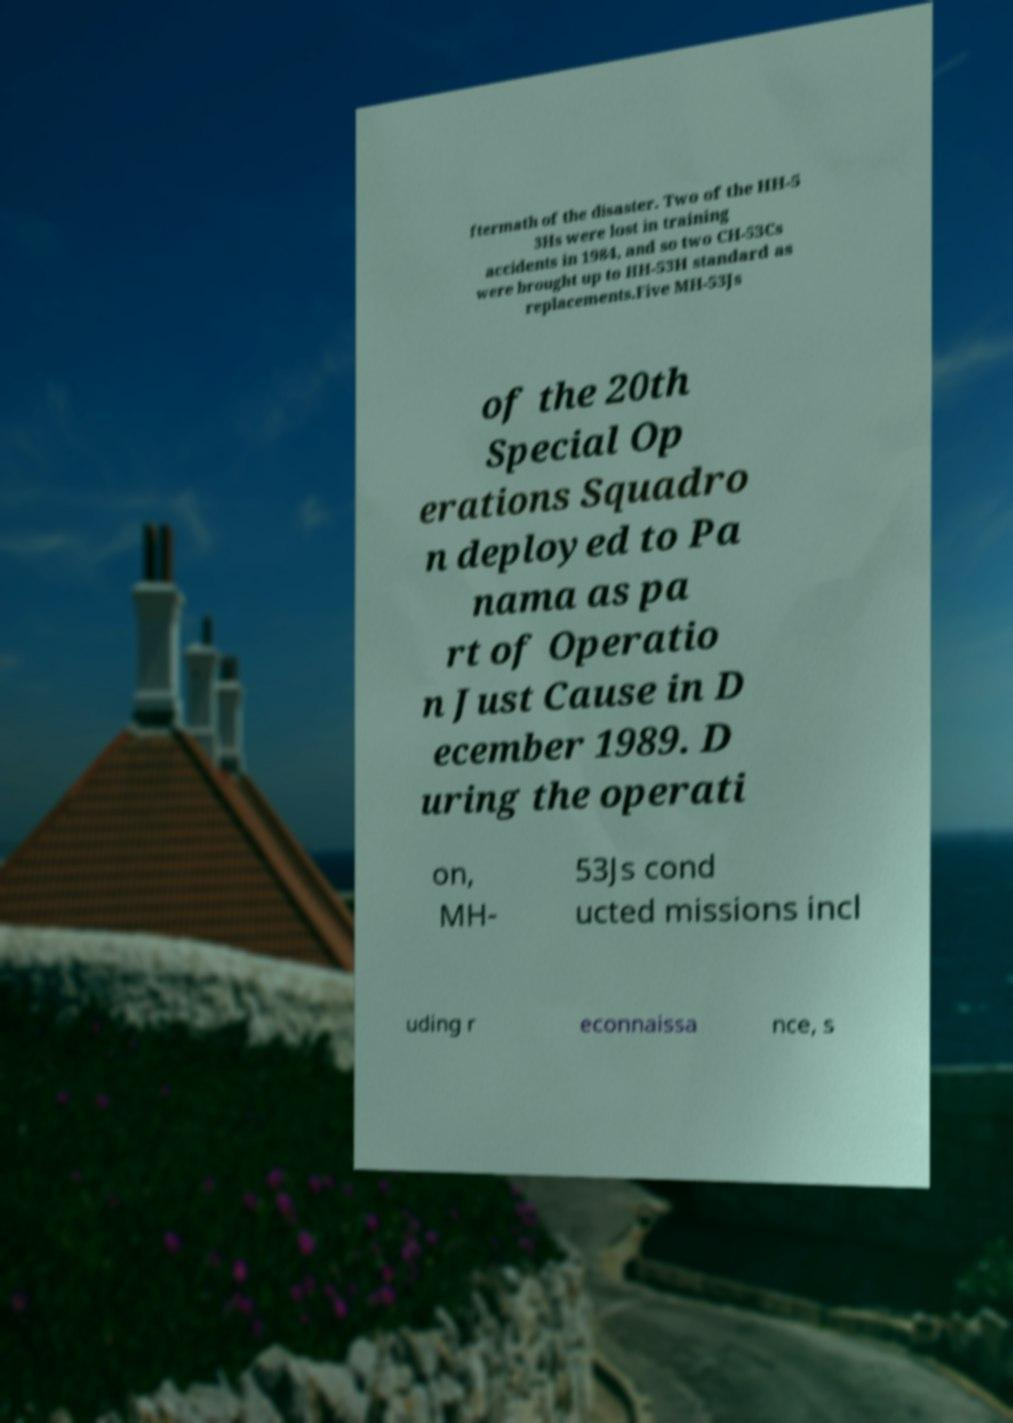I need the written content from this picture converted into text. Can you do that? ftermath of the disaster. Two of the HH-5 3Hs were lost in training accidents in 1984, and so two CH-53Cs were brought up to HH-53H standard as replacements.Five MH-53Js of the 20th Special Op erations Squadro n deployed to Pa nama as pa rt of Operatio n Just Cause in D ecember 1989. D uring the operati on, MH- 53Js cond ucted missions incl uding r econnaissa nce, s 